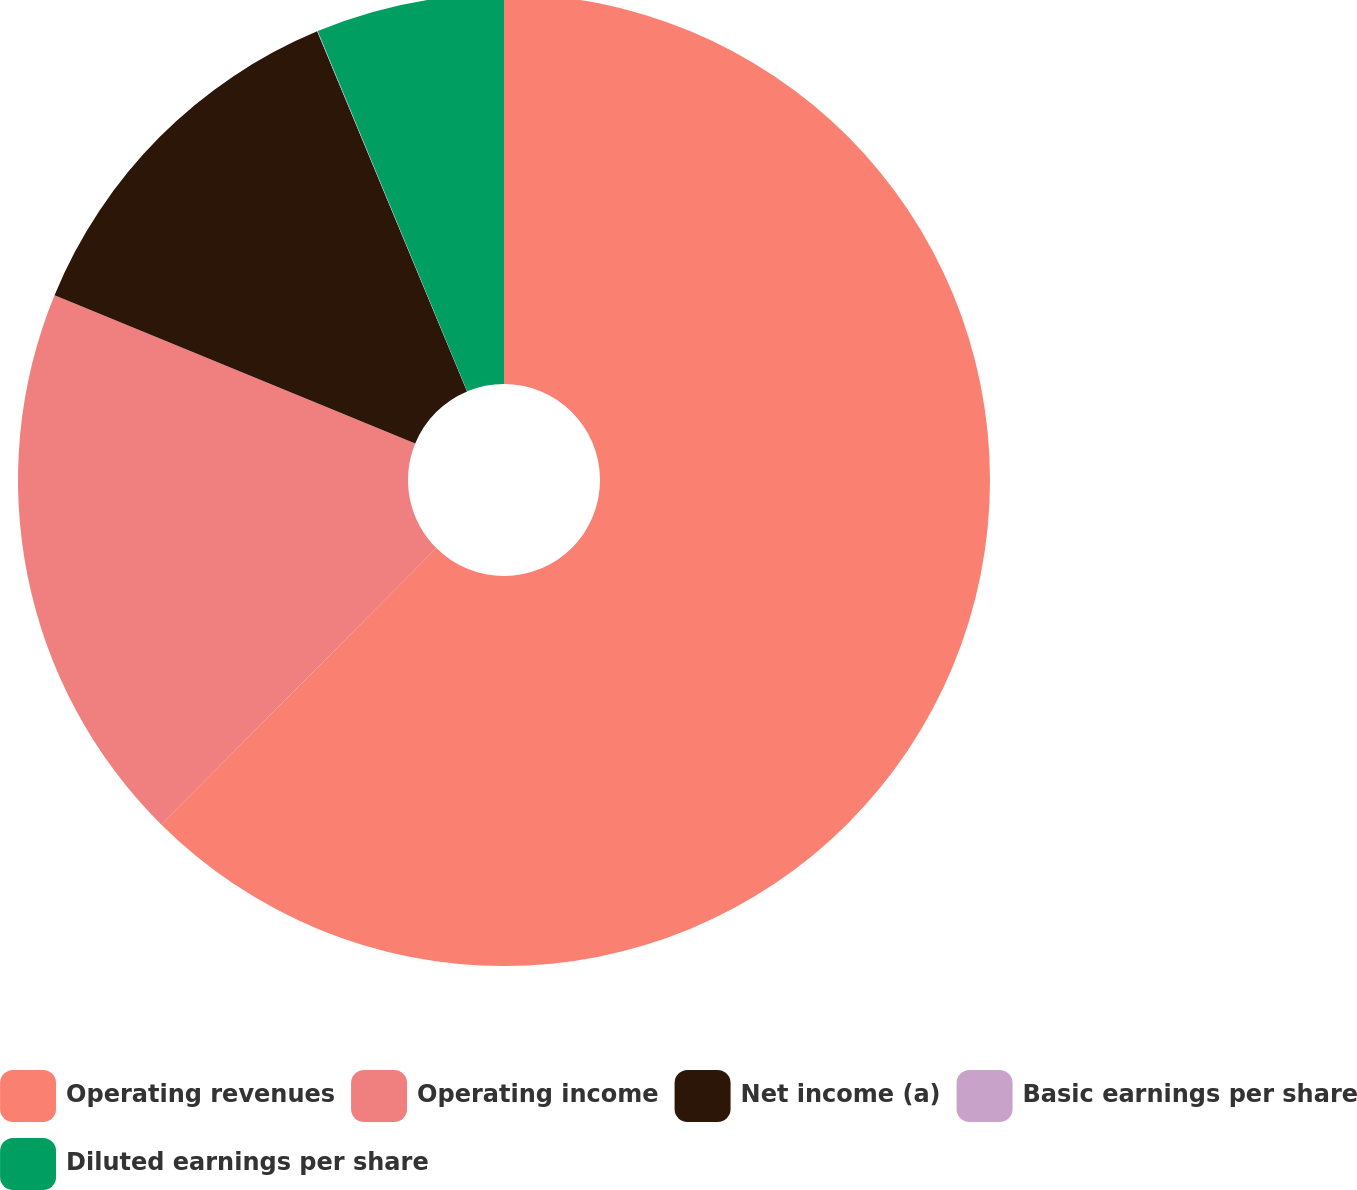Convert chart to OTSL. <chart><loc_0><loc_0><loc_500><loc_500><pie_chart><fcel>Operating revenues<fcel>Operating income<fcel>Net income (a)<fcel>Basic earnings per share<fcel>Diluted earnings per share<nl><fcel>62.46%<fcel>18.75%<fcel>12.51%<fcel>0.02%<fcel>6.26%<nl></chart> 